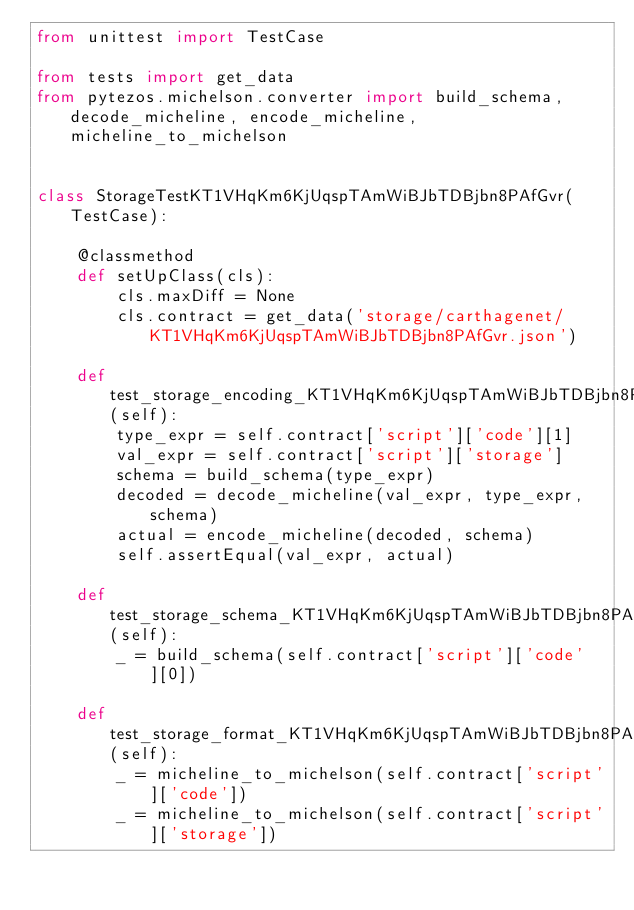Convert code to text. <code><loc_0><loc_0><loc_500><loc_500><_Python_>from unittest import TestCase

from tests import get_data
from pytezos.michelson.converter import build_schema, decode_micheline, encode_micheline, micheline_to_michelson


class StorageTestKT1VHqKm6KjUqspTAmWiBJbTDBjbn8PAfGvr(TestCase):

    @classmethod
    def setUpClass(cls):
        cls.maxDiff = None
        cls.contract = get_data('storage/carthagenet/KT1VHqKm6KjUqspTAmWiBJbTDBjbn8PAfGvr.json')

    def test_storage_encoding_KT1VHqKm6KjUqspTAmWiBJbTDBjbn8PAfGvr(self):
        type_expr = self.contract['script']['code'][1]
        val_expr = self.contract['script']['storage']
        schema = build_schema(type_expr)
        decoded = decode_micheline(val_expr, type_expr, schema)
        actual = encode_micheline(decoded, schema)
        self.assertEqual(val_expr, actual)

    def test_storage_schema_KT1VHqKm6KjUqspTAmWiBJbTDBjbn8PAfGvr(self):
        _ = build_schema(self.contract['script']['code'][0])

    def test_storage_format_KT1VHqKm6KjUqspTAmWiBJbTDBjbn8PAfGvr(self):
        _ = micheline_to_michelson(self.contract['script']['code'])
        _ = micheline_to_michelson(self.contract['script']['storage'])
</code> 